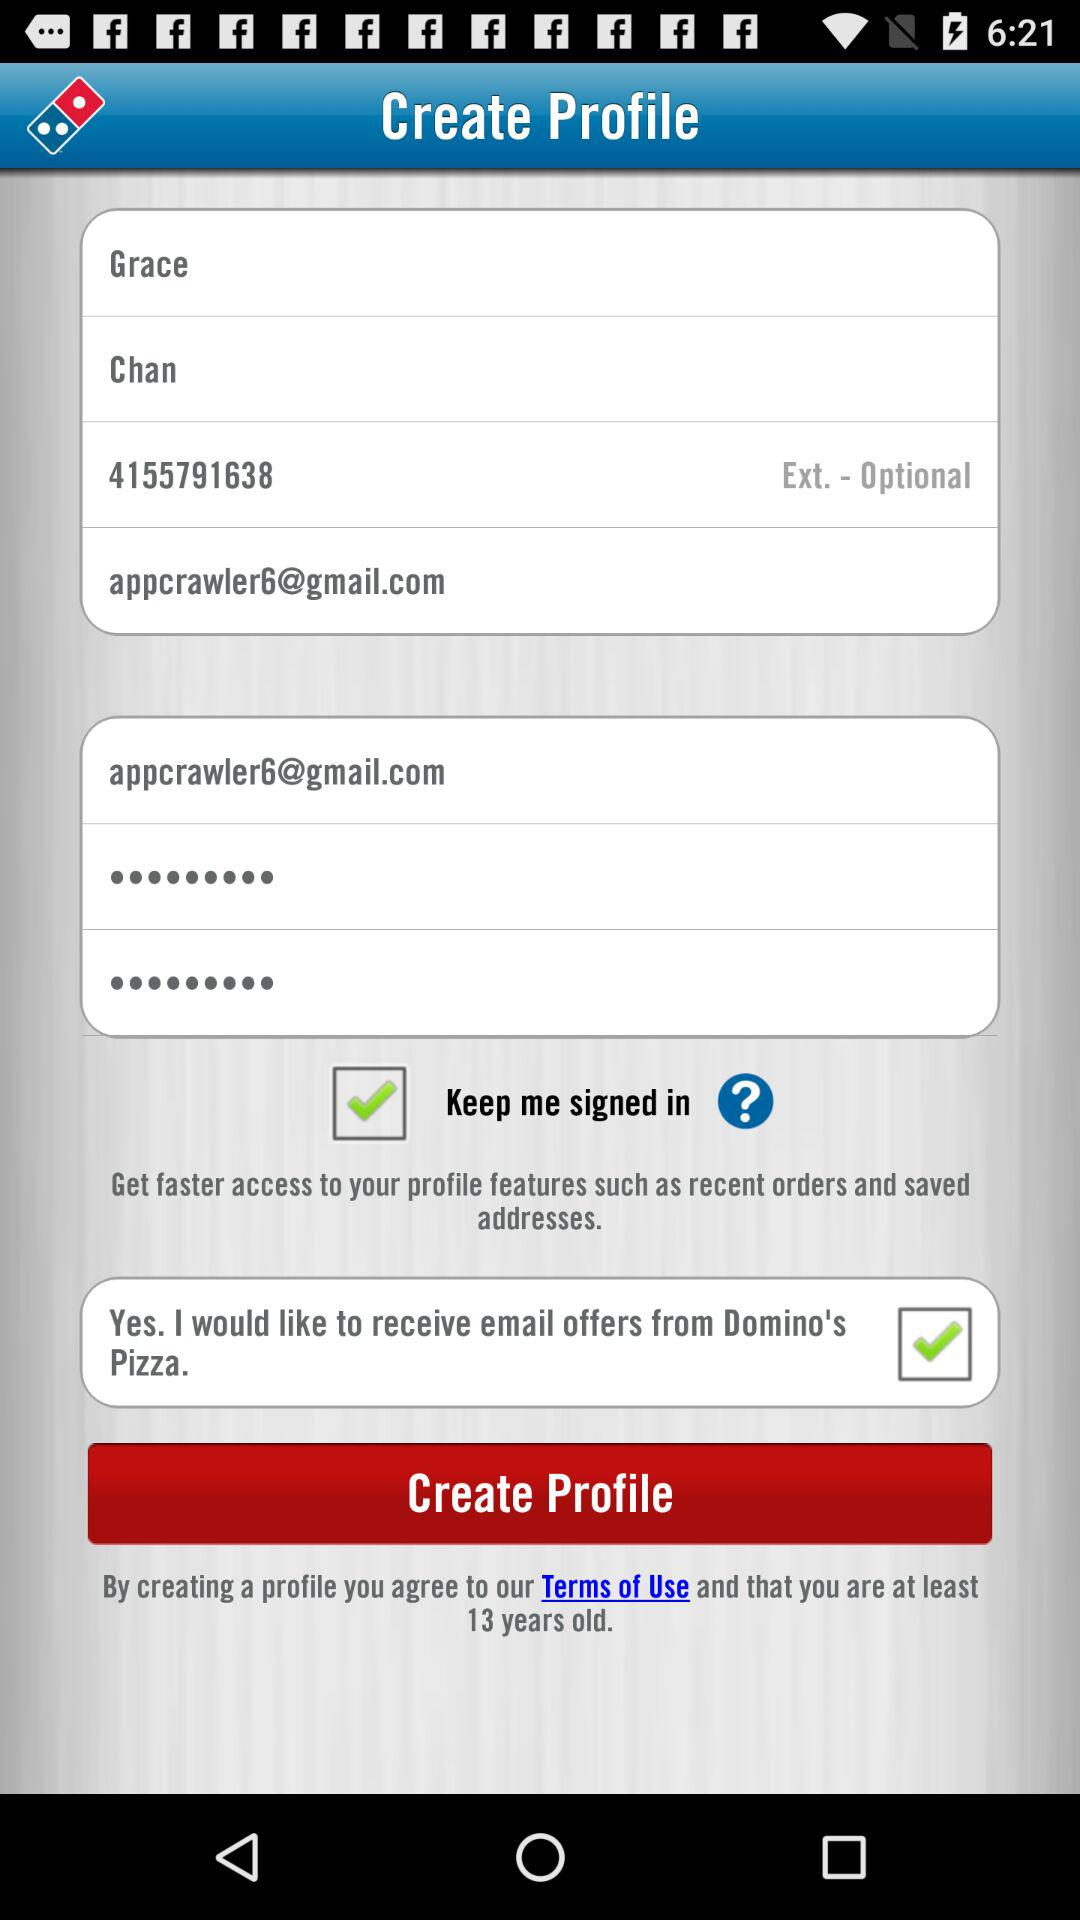What is the status of "Yes. I would like to receive email offers from Domino's Pizza"? The status is "on". 